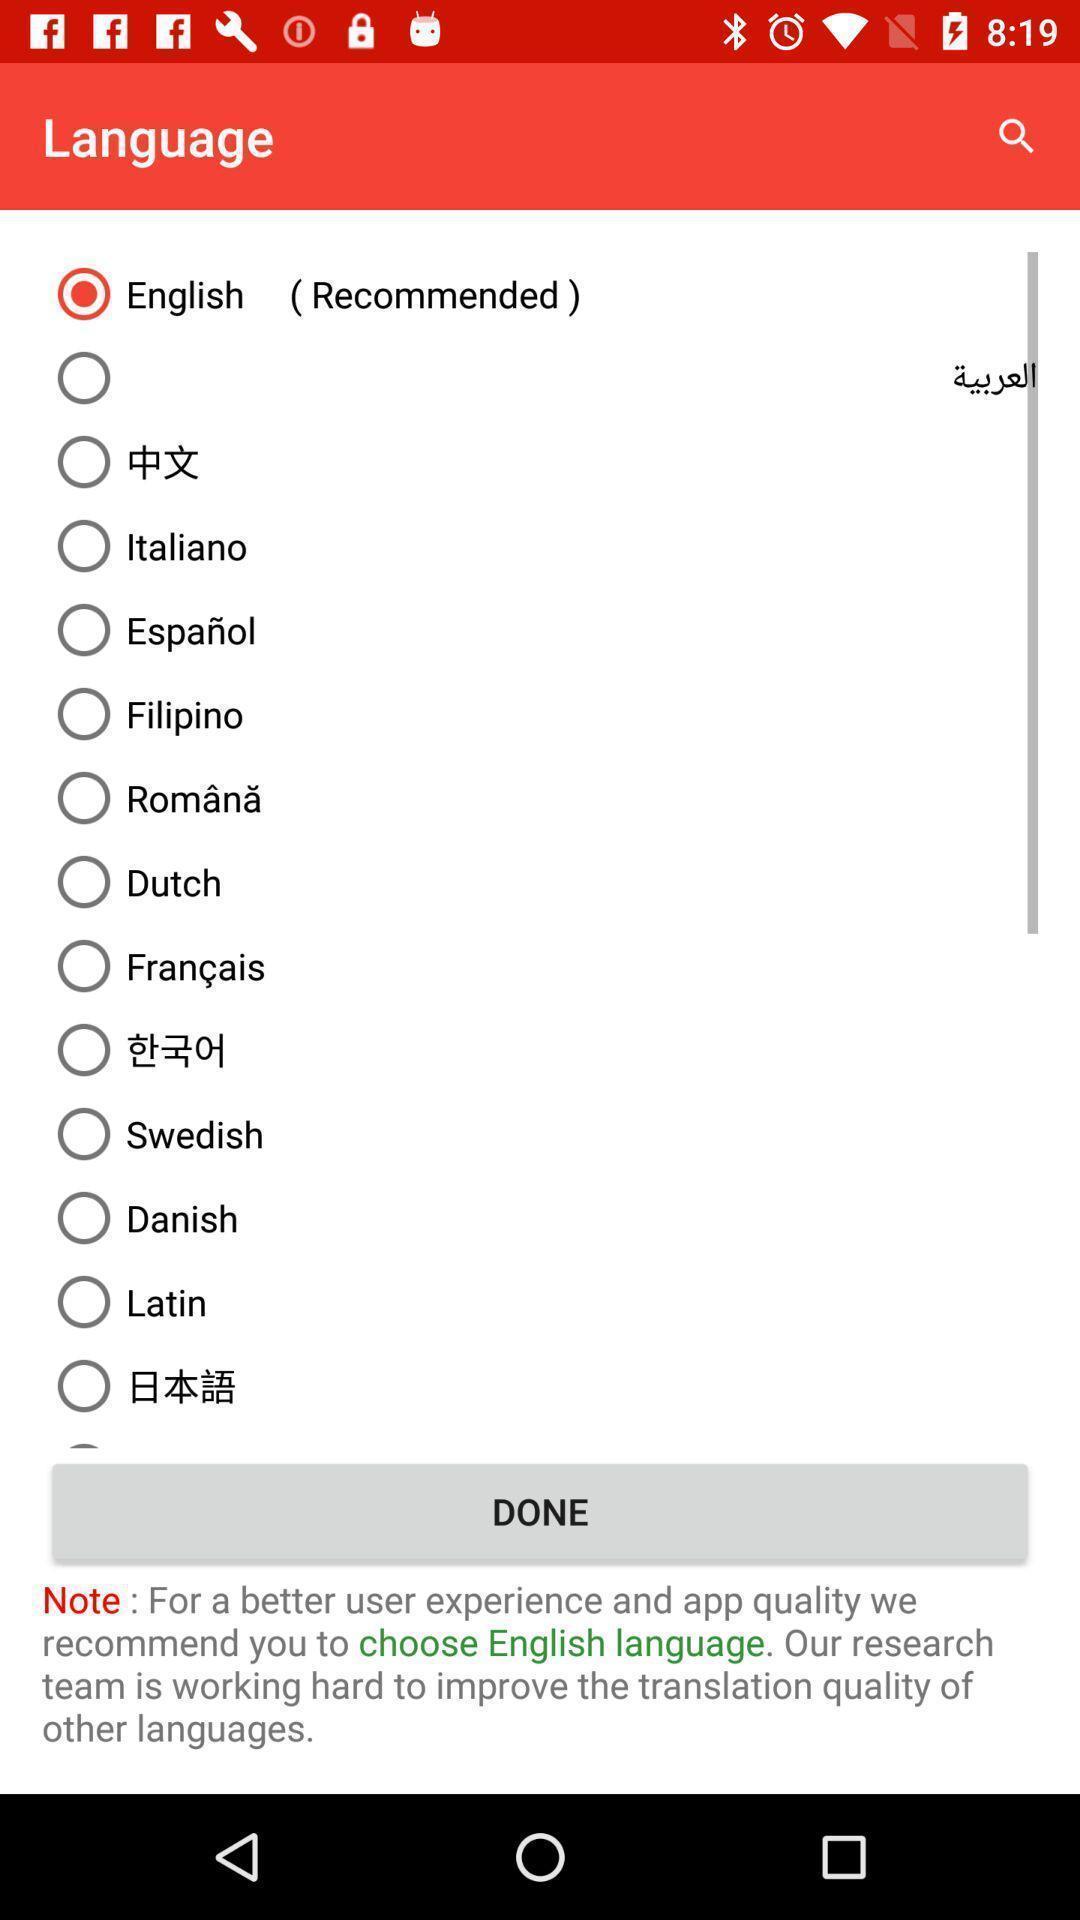Describe the key features of this screenshot. Various language list displayed. 